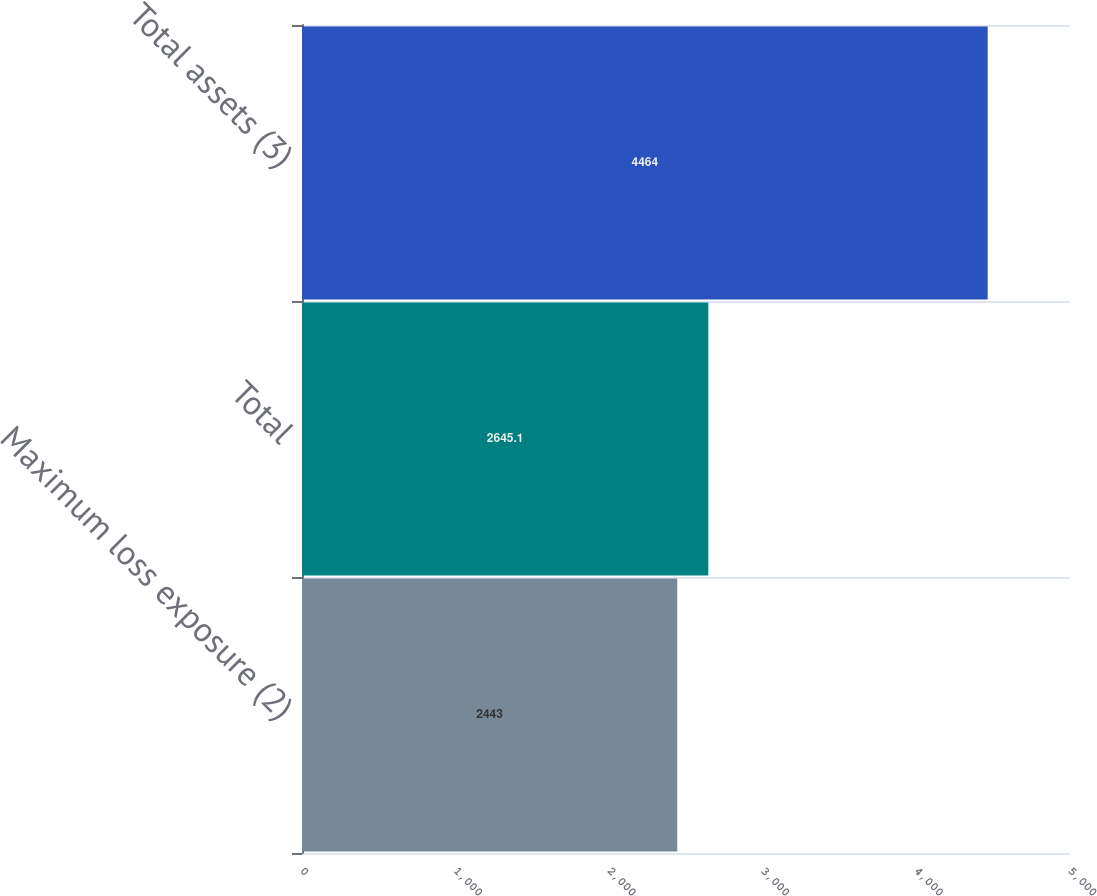<chart> <loc_0><loc_0><loc_500><loc_500><bar_chart><fcel>Maximum loss exposure (2)<fcel>Total<fcel>Total assets (3)<nl><fcel>2443<fcel>2645.1<fcel>4464<nl></chart> 